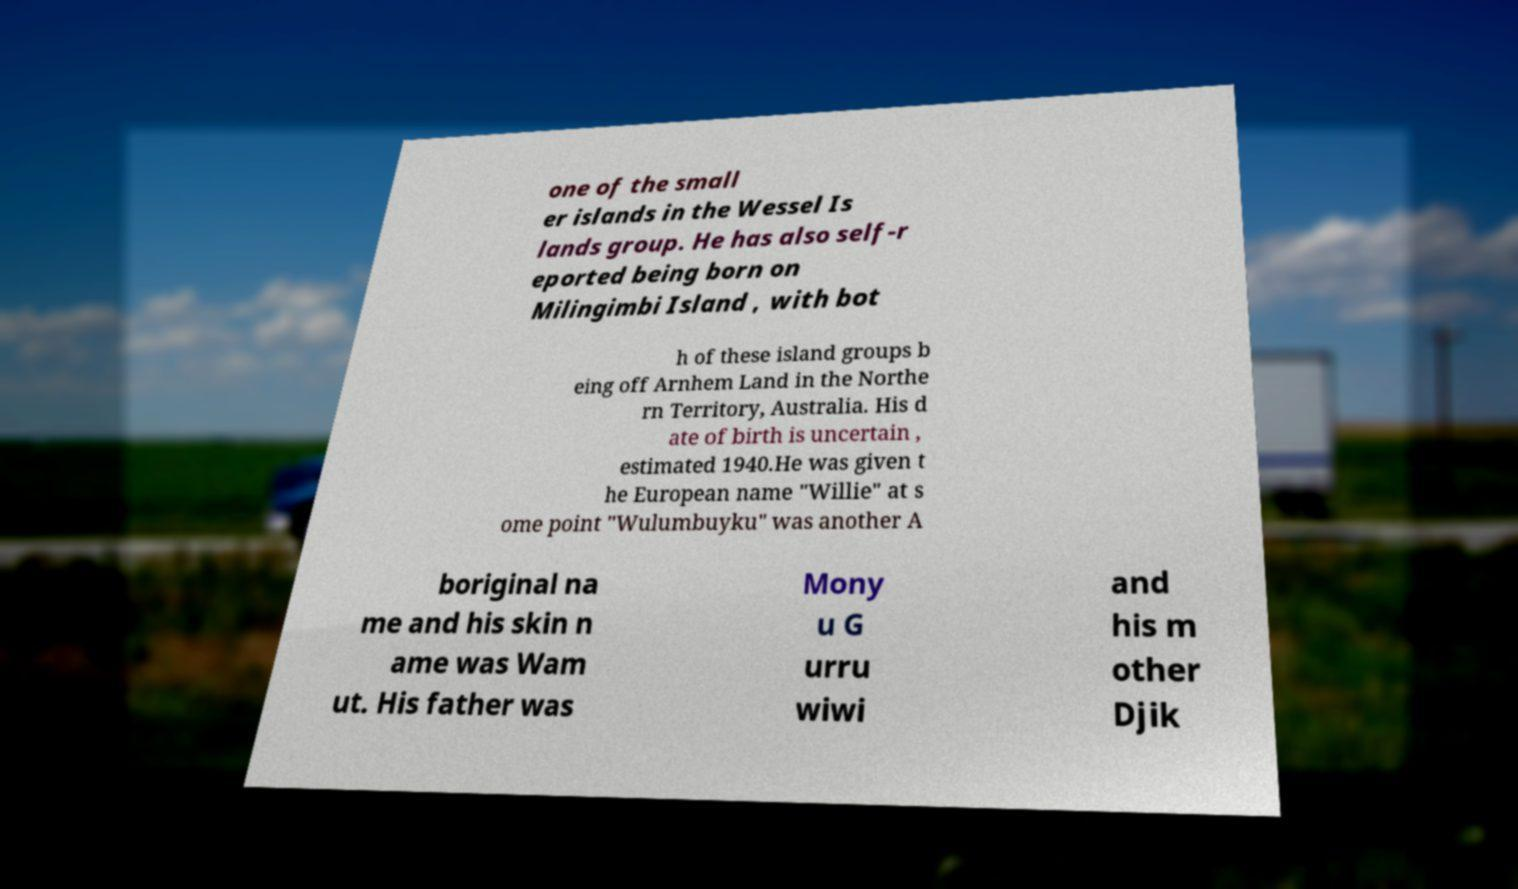For documentation purposes, I need the text within this image transcribed. Could you provide that? one of the small er islands in the Wessel Is lands group. He has also self-r eported being born on Milingimbi Island , with bot h of these island groups b eing off Arnhem Land in the Northe rn Territory, Australia. His d ate of birth is uncertain , estimated 1940.He was given t he European name "Willie" at s ome point "Wulumbuyku" was another A boriginal na me and his skin n ame was Wam ut. His father was Mony u G urru wiwi and his m other Djik 